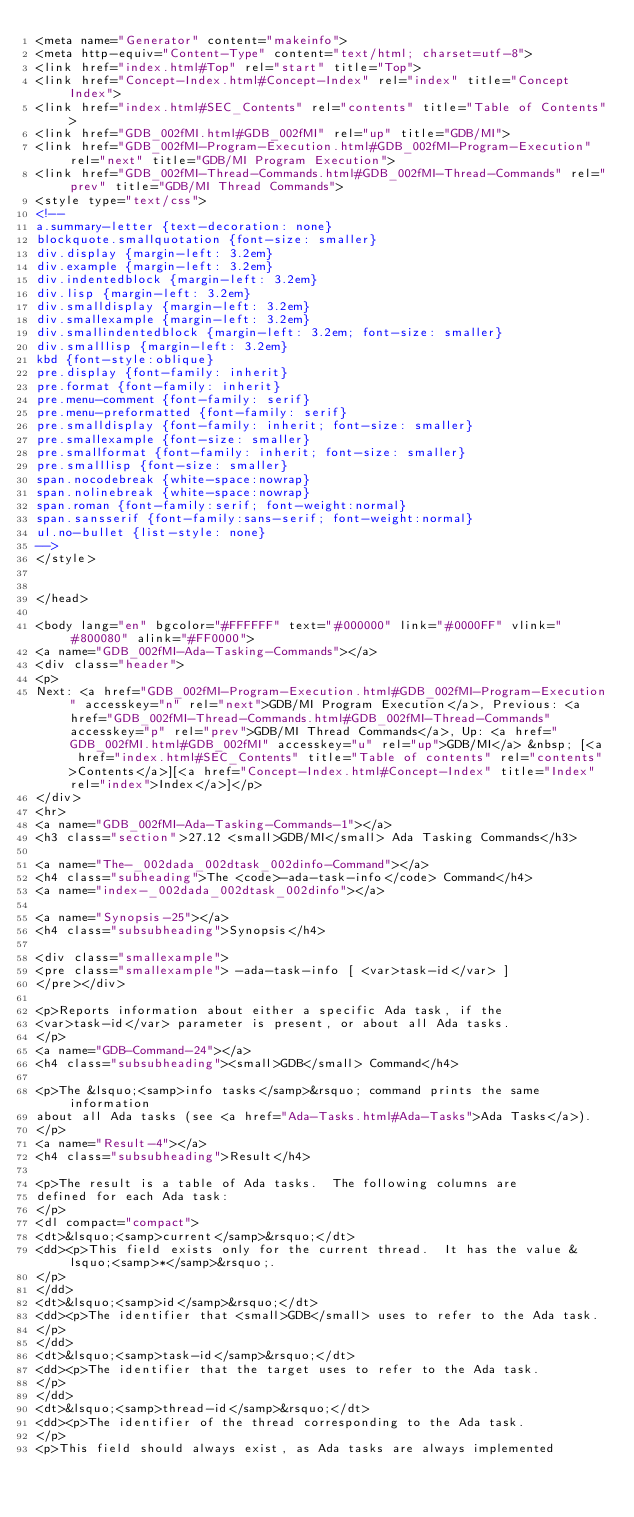<code> <loc_0><loc_0><loc_500><loc_500><_HTML_><meta name="Generator" content="makeinfo">
<meta http-equiv="Content-Type" content="text/html; charset=utf-8">
<link href="index.html#Top" rel="start" title="Top">
<link href="Concept-Index.html#Concept-Index" rel="index" title="Concept Index">
<link href="index.html#SEC_Contents" rel="contents" title="Table of Contents">
<link href="GDB_002fMI.html#GDB_002fMI" rel="up" title="GDB/MI">
<link href="GDB_002fMI-Program-Execution.html#GDB_002fMI-Program-Execution" rel="next" title="GDB/MI Program Execution">
<link href="GDB_002fMI-Thread-Commands.html#GDB_002fMI-Thread-Commands" rel="prev" title="GDB/MI Thread Commands">
<style type="text/css">
<!--
a.summary-letter {text-decoration: none}
blockquote.smallquotation {font-size: smaller}
div.display {margin-left: 3.2em}
div.example {margin-left: 3.2em}
div.indentedblock {margin-left: 3.2em}
div.lisp {margin-left: 3.2em}
div.smalldisplay {margin-left: 3.2em}
div.smallexample {margin-left: 3.2em}
div.smallindentedblock {margin-left: 3.2em; font-size: smaller}
div.smalllisp {margin-left: 3.2em}
kbd {font-style:oblique}
pre.display {font-family: inherit}
pre.format {font-family: inherit}
pre.menu-comment {font-family: serif}
pre.menu-preformatted {font-family: serif}
pre.smalldisplay {font-family: inherit; font-size: smaller}
pre.smallexample {font-size: smaller}
pre.smallformat {font-family: inherit; font-size: smaller}
pre.smalllisp {font-size: smaller}
span.nocodebreak {white-space:nowrap}
span.nolinebreak {white-space:nowrap}
span.roman {font-family:serif; font-weight:normal}
span.sansserif {font-family:sans-serif; font-weight:normal}
ul.no-bullet {list-style: none}
-->
</style>


</head>

<body lang="en" bgcolor="#FFFFFF" text="#000000" link="#0000FF" vlink="#800080" alink="#FF0000">
<a name="GDB_002fMI-Ada-Tasking-Commands"></a>
<div class="header">
<p>
Next: <a href="GDB_002fMI-Program-Execution.html#GDB_002fMI-Program-Execution" accesskey="n" rel="next">GDB/MI Program Execution</a>, Previous: <a href="GDB_002fMI-Thread-Commands.html#GDB_002fMI-Thread-Commands" accesskey="p" rel="prev">GDB/MI Thread Commands</a>, Up: <a href="GDB_002fMI.html#GDB_002fMI" accesskey="u" rel="up">GDB/MI</a> &nbsp; [<a href="index.html#SEC_Contents" title="Table of contents" rel="contents">Contents</a>][<a href="Concept-Index.html#Concept-Index" title="Index" rel="index">Index</a>]</p>
</div>
<hr>
<a name="GDB_002fMI-Ada-Tasking-Commands-1"></a>
<h3 class="section">27.12 <small>GDB/MI</small> Ada Tasking Commands</h3>

<a name="The-_002dada_002dtask_002dinfo-Command"></a>
<h4 class="subheading">The <code>-ada-task-info</code> Command</h4>
<a name="index-_002dada_002dtask_002dinfo"></a>

<a name="Synopsis-25"></a>
<h4 class="subsubheading">Synopsis</h4>

<div class="smallexample">
<pre class="smallexample"> -ada-task-info [ <var>task-id</var> ]
</pre></div>

<p>Reports information about either a specific Ada task, if the
<var>task-id</var> parameter is present, or about all Ada tasks.
</p>
<a name="GDB-Command-24"></a>
<h4 class="subsubheading"><small>GDB</small> Command</h4>

<p>The &lsquo;<samp>info tasks</samp>&rsquo; command prints the same information
about all Ada tasks (see <a href="Ada-Tasks.html#Ada-Tasks">Ada Tasks</a>).
</p>
<a name="Result-4"></a>
<h4 class="subsubheading">Result</h4>

<p>The result is a table of Ada tasks.  The following columns are
defined for each Ada task:
</p>
<dl compact="compact">
<dt>&lsquo;<samp>current</samp>&rsquo;</dt>
<dd><p>This field exists only for the current thread.  It has the value &lsquo;<samp>*</samp>&rsquo;.
</p>
</dd>
<dt>&lsquo;<samp>id</samp>&rsquo;</dt>
<dd><p>The identifier that <small>GDB</small> uses to refer to the Ada task.
</p>
</dd>
<dt>&lsquo;<samp>task-id</samp>&rsquo;</dt>
<dd><p>The identifier that the target uses to refer to the Ada task.
</p>
</dd>
<dt>&lsquo;<samp>thread-id</samp>&rsquo;</dt>
<dd><p>The identifier of the thread corresponding to the Ada task.
</p>
<p>This field should always exist, as Ada tasks are always implemented</code> 